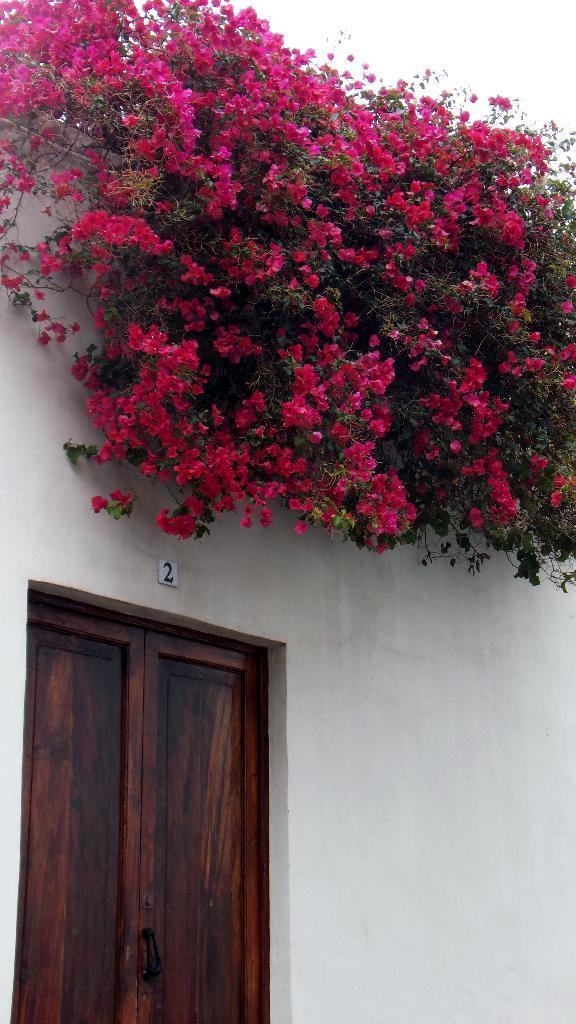Could you give a brief overview of what you see in this image? In this image I can see few pink color flowers on the white color building. I can see a wooden door. 